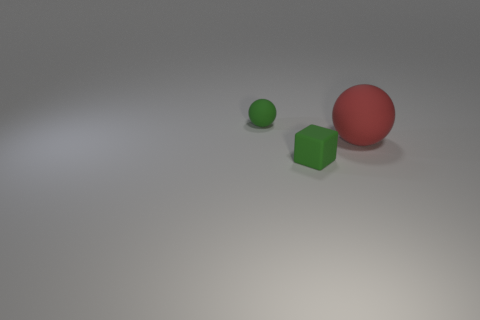The thing that is the same color as the tiny ball is what shape?
Your response must be concise. Cube. How many other matte objects have the same shape as the red object?
Provide a succinct answer. 1. There is a large red object that is the same material as the small green ball; what shape is it?
Provide a succinct answer. Sphere. What number of brown objects are either tiny balls or spheres?
Ensure brevity in your answer.  0. Are there any big red balls in front of the rubber block?
Your answer should be compact. No. There is a tiny object that is in front of the green ball; does it have the same shape as the thing that is to the left of the block?
Ensure brevity in your answer.  No. There is a tiny thing that is the same shape as the big red rubber thing; what is it made of?
Ensure brevity in your answer.  Rubber. What number of cylinders are tiny cyan matte things or small green matte objects?
Offer a very short reply. 0. What number of red objects have the same material as the green block?
Ensure brevity in your answer.  1. Is the green cube left of the red rubber thing made of the same material as the ball that is in front of the small sphere?
Give a very brief answer. Yes. 